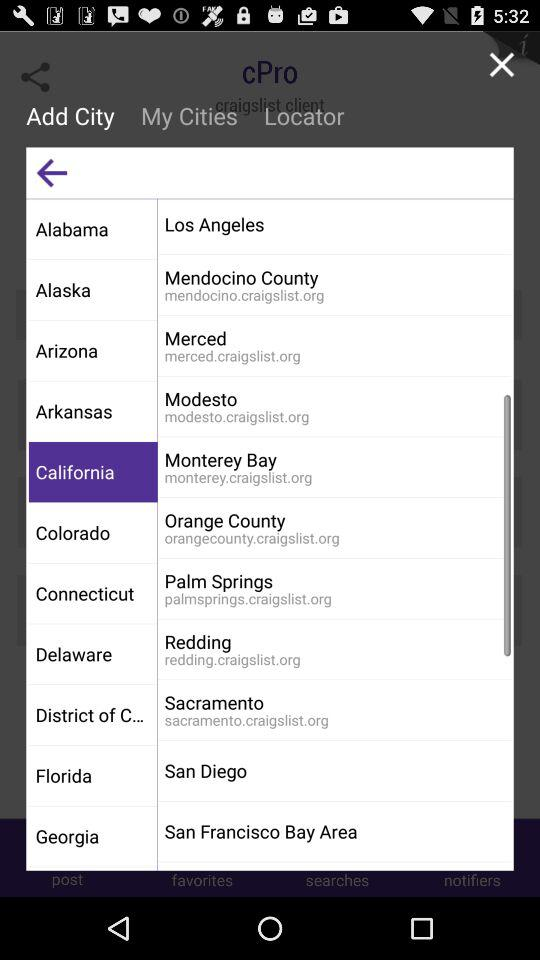Where is Palm Springs located? It is located in California. 